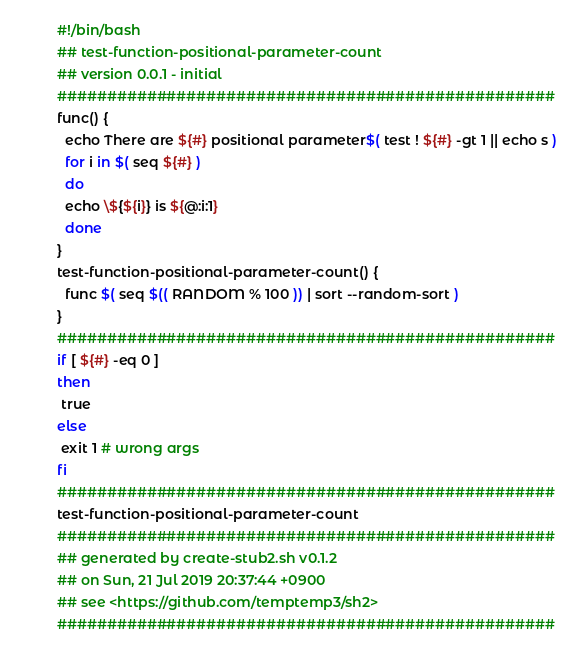<code> <loc_0><loc_0><loc_500><loc_500><_Bash_>#!/bin/bash
## test-function-positional-parameter-count
## version 0.0.1 - initial
##################################################
func() {
  echo There are ${#} positional parameter$( test ! ${#} -gt 1 || echo s )
  for i in $( seq ${#} )
  do
  echo \${${i}} is ${@:i:1}
  done
}
test-function-positional-parameter-count() {
  func $( seq $(( RANDOM % 100 )) | sort --random-sort )
}
##################################################
if [ ${#} -eq 0 ] 
then
 true
else
 exit 1 # wrong args
fi
##################################################
test-function-positional-parameter-count
##################################################
## generated by create-stub2.sh v0.1.2
## on Sun, 21 Jul 2019 20:37:44 +0900
## see <https://github.com/temptemp3/sh2>
##################################################
</code> 